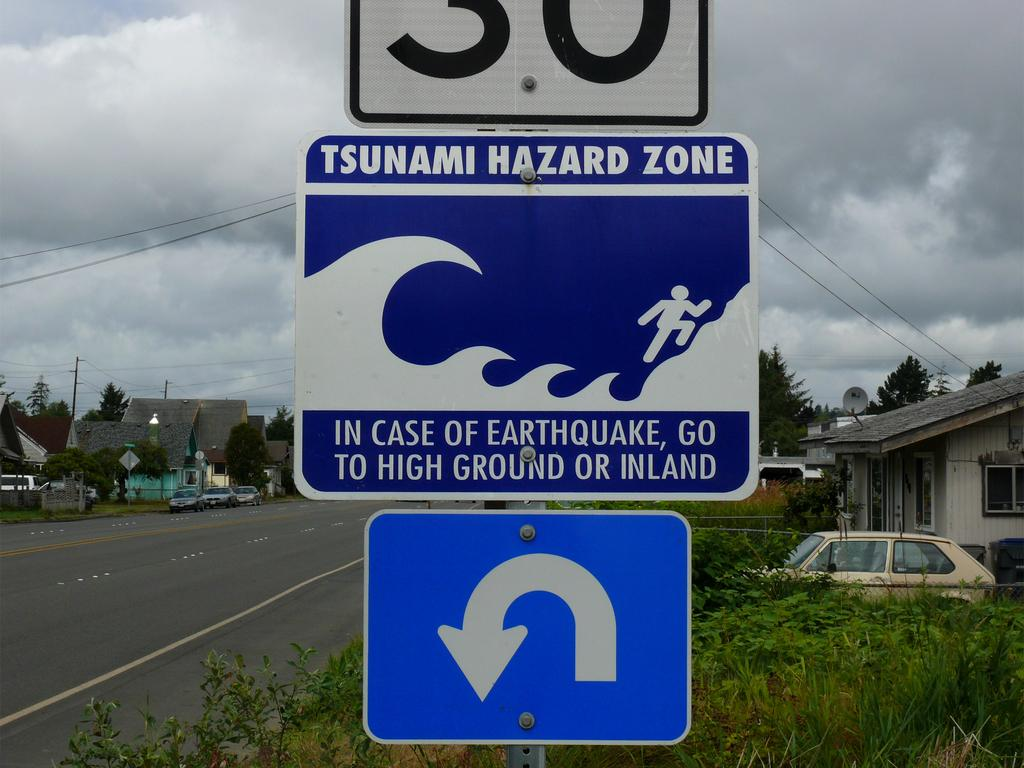What is attached to the pole in the image? There are boards on a pole in the image. What can be seen in the background of the image? There are trees, plants, houses, poles, roads, vehicles, and a cloudy sky visible in the background of the image. Can you tell me how many shoes are on the road in the image? There are no shoes present in the image; it only features boards on a pole and various elements in the background. What type of eggnog can be seen in the image? There is no eggnog present in the image. 